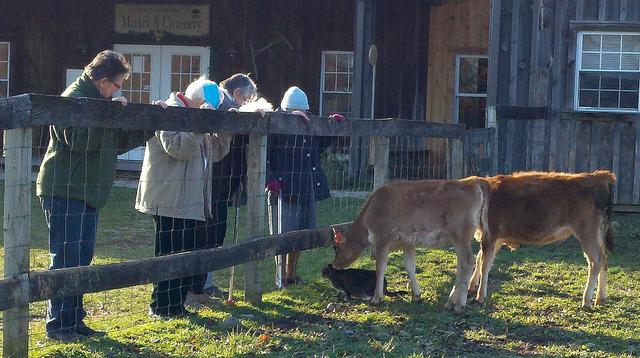Is this a farm?
Write a very short answer. Yes. Are they feeding the animals?
Give a very brief answer. No. Is this in nature?
Answer briefly. No. How many human figures are in the photo?
Quick response, please. 4. 